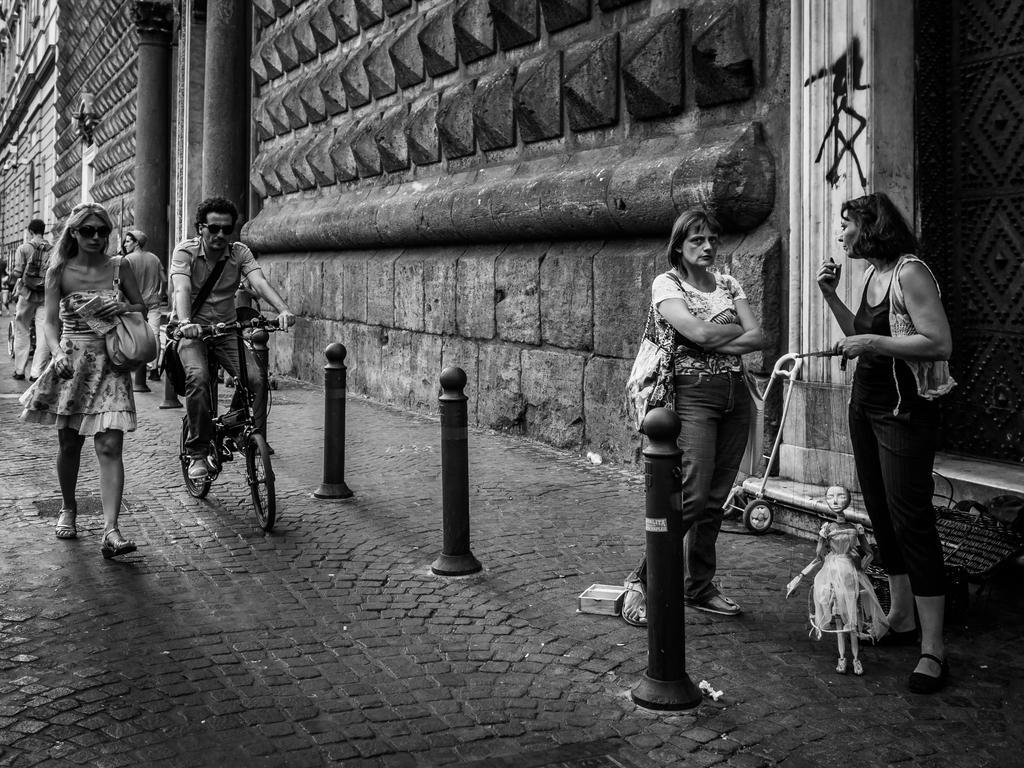Describe this image in one or two sentences. In this image we can see a black and white image. In this image we can see some persons, poles, bicycles, bags and other objects. In the background of the image there is a wall, poles and other objects. At the bottom of the image there is the floor. 